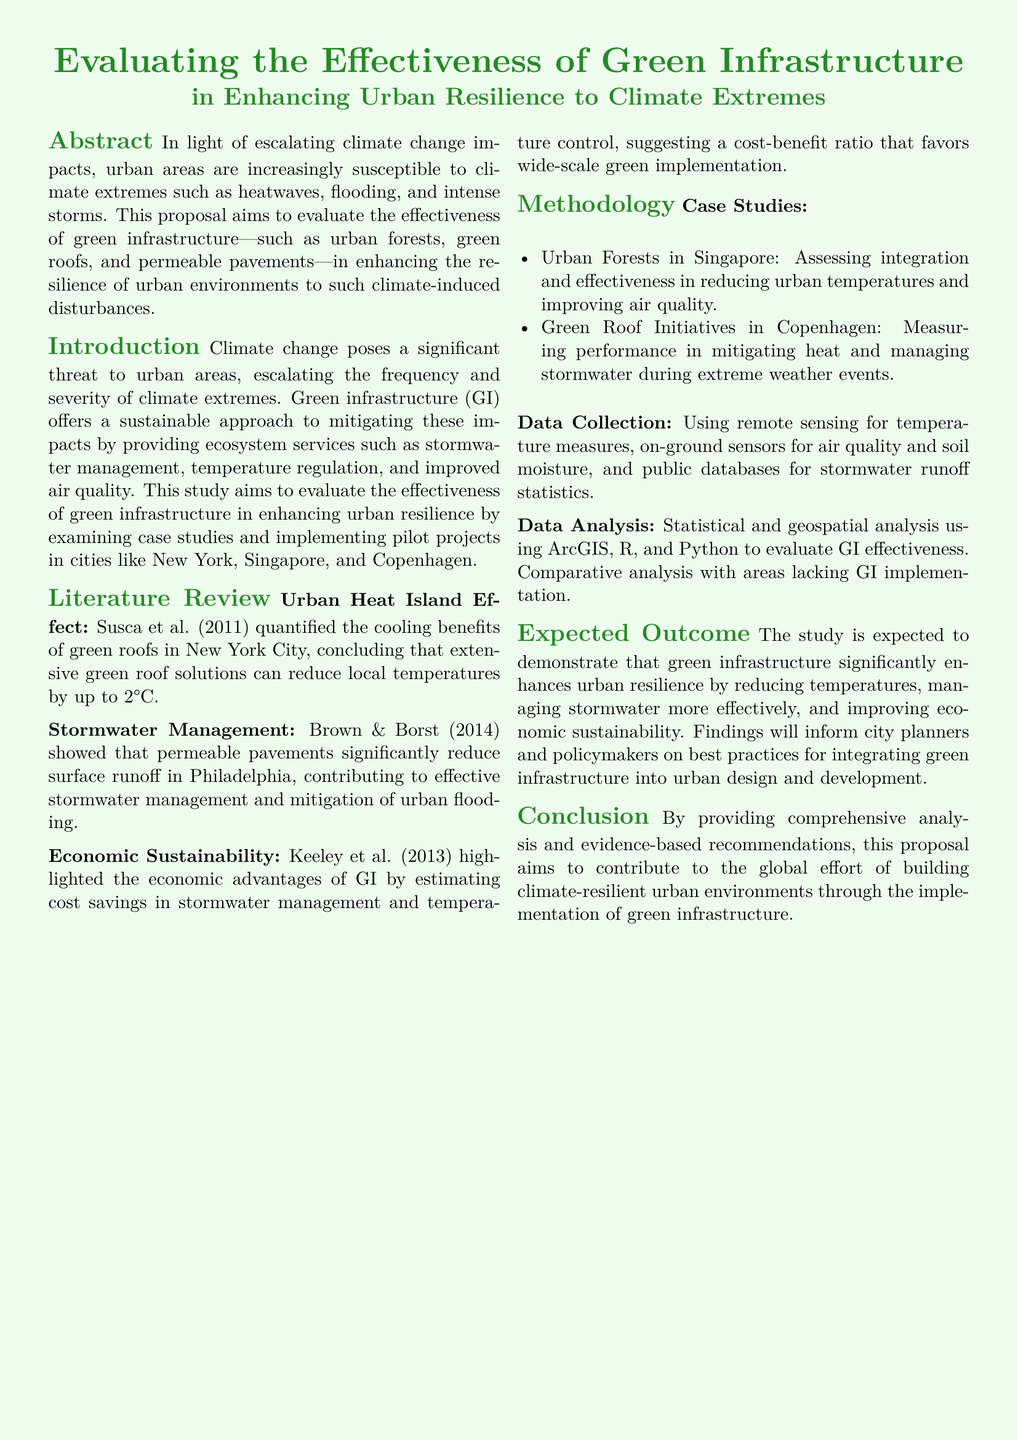What is the main focus of the proposal? The main focus is evaluating the effectiveness of green infrastructure in enhancing urban resilience to climate extremes.
Answer: Evaluating the effectiveness of green infrastructure Which three cities are mentioned for case studies? The cities mentioned include New York, Singapore, and Copenhagen.
Answer: New York, Singapore, Copenhagen What is one benefit of green roofs as noted in the literature review? One benefit mentioned is that green roofs can reduce local temperatures by up to 2°C.
Answer: Reduce local temperatures by up to 2°C What method is used for data collection? Remote sensing is used for temperature measures, along with other on-ground sensors.
Answer: Remote sensing What is the expected outcome of the study? The expected outcome is that green infrastructure significantly enhances urban resilience.
Answer: Significantly enhances urban resilience What is one parameter measured in the green roof initiatives in Copenhagen? One parameter measured is the performance in mitigating heat.
Answer: Performance in mitigating heat Who are the primary audience for the findings of the study? The primary audience includes city planners and policymakers.
Answer: City planners and policymakers What analysis tools are mentioned for data analysis? The tools mentioned include ArcGIS, R, and Python.
Answer: ArcGIS, R, and Python 